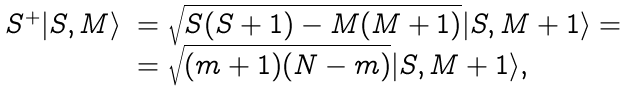<formula> <loc_0><loc_0><loc_500><loc_500>\begin{array} { l l } S ^ { + } | S , M \rangle & = \sqrt { S ( S + 1 ) - M ( M + 1 ) } | S , M + 1 \rangle = \\ & = \sqrt { ( m + 1 ) ( N - m ) } | S , M + 1 \rangle , \end{array}</formula> 